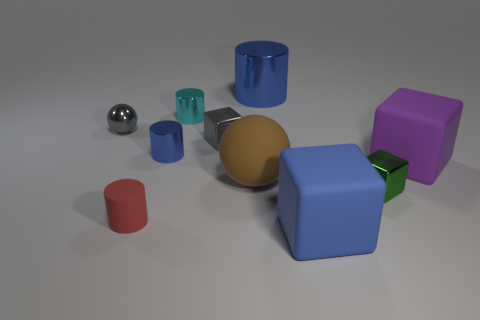What number of cubes are on the right side of the blue matte thing and in front of the tiny green object? Observing the image, there are no cubes positioned to the right side of the blue matte cube and in front of the tiny green object. All cubes and objects are clearly separated and none meet the criteria described in the question. 